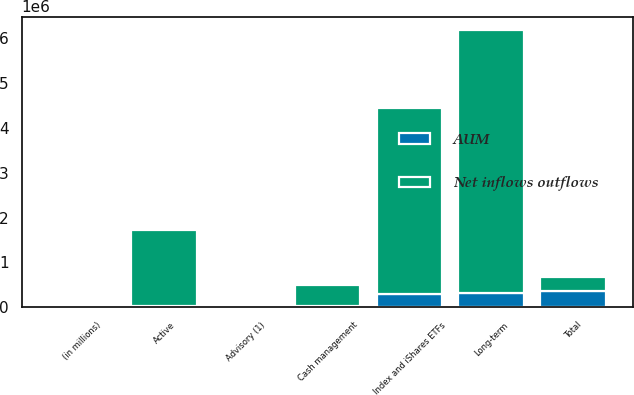Convert chart. <chart><loc_0><loc_0><loc_500><loc_500><stacked_bar_chart><ecel><fcel>(in millions)<fcel>Active<fcel>Index and iShares ETFs<fcel>Long-term<fcel>Cash management<fcel>Advisory (1)<fcel>Total<nl><fcel>Net inflows outflows<fcel>2017<fcel>1.696e+06<fcel>4.14073e+06<fcel>5.83673e+06<fcel>449949<fcel>1515<fcel>305791<nl><fcel>AUM<fcel>2017<fcel>24449<fcel>305791<fcel>330240<fcel>38259<fcel>1245<fcel>367254<nl></chart> 